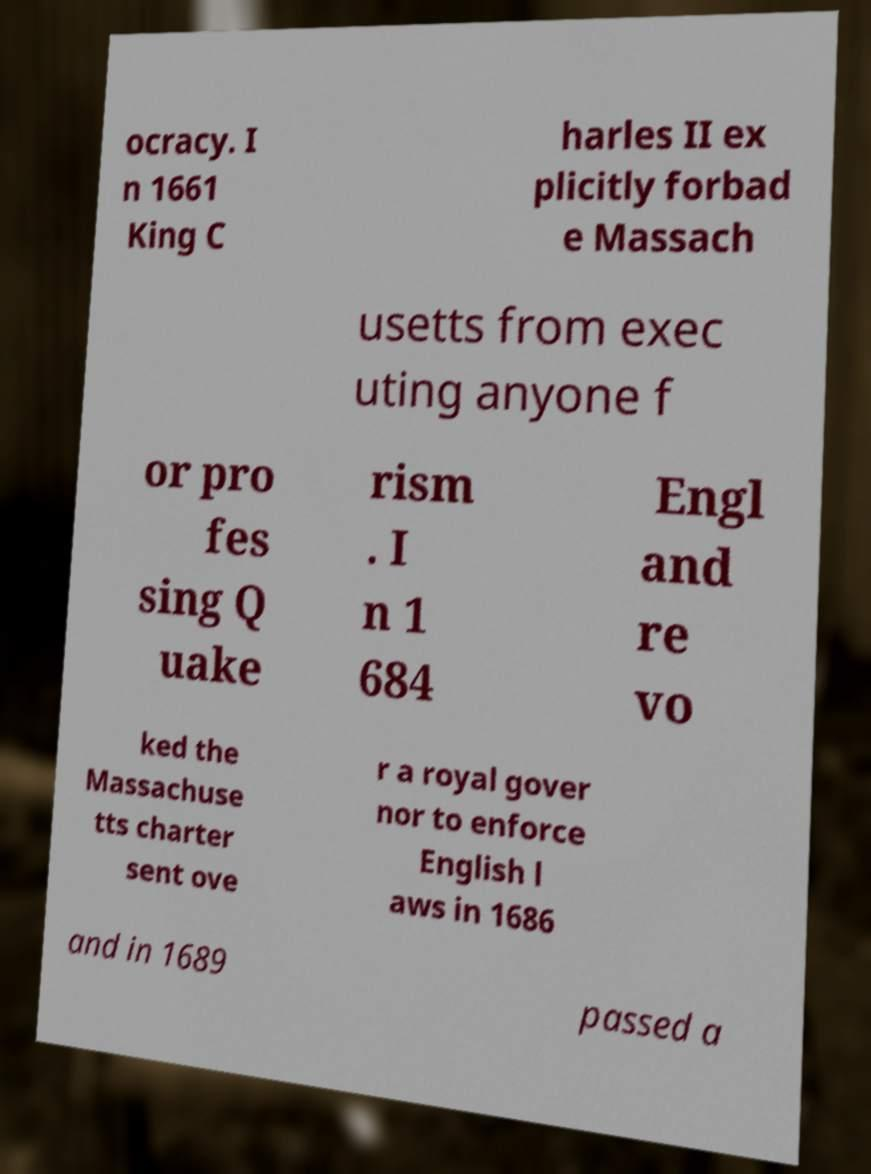For documentation purposes, I need the text within this image transcribed. Could you provide that? ocracy. I n 1661 King C harles II ex plicitly forbad e Massach usetts from exec uting anyone f or pro fes sing Q uake rism . I n 1 684 Engl and re vo ked the Massachuse tts charter sent ove r a royal gover nor to enforce English l aws in 1686 and in 1689 passed a 